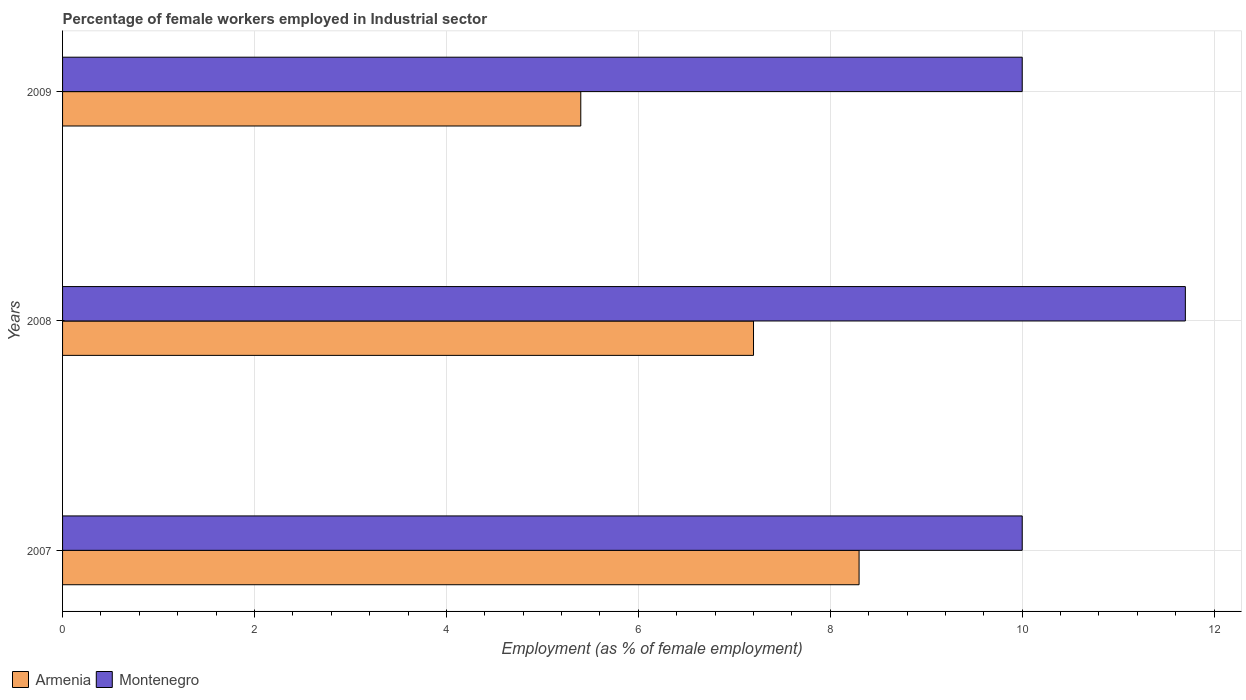Are the number of bars per tick equal to the number of legend labels?
Keep it short and to the point. Yes. Are the number of bars on each tick of the Y-axis equal?
Keep it short and to the point. Yes. How many bars are there on the 1st tick from the top?
Give a very brief answer. 2. What is the label of the 2nd group of bars from the top?
Your response must be concise. 2008. In how many cases, is the number of bars for a given year not equal to the number of legend labels?
Keep it short and to the point. 0. Across all years, what is the maximum percentage of females employed in Industrial sector in Montenegro?
Your answer should be very brief. 11.7. In which year was the percentage of females employed in Industrial sector in Montenegro minimum?
Provide a succinct answer. 2007. What is the total percentage of females employed in Industrial sector in Montenegro in the graph?
Provide a short and direct response. 31.7. What is the difference between the percentage of females employed in Industrial sector in Montenegro in 2009 and the percentage of females employed in Industrial sector in Armenia in 2007?
Offer a terse response. 1.7. What is the average percentage of females employed in Industrial sector in Armenia per year?
Make the answer very short. 6.97. In the year 2007, what is the difference between the percentage of females employed in Industrial sector in Armenia and percentage of females employed in Industrial sector in Montenegro?
Provide a short and direct response. -1.7. In how many years, is the percentage of females employed in Industrial sector in Armenia greater than 6 %?
Your answer should be very brief. 2. What is the ratio of the percentage of females employed in Industrial sector in Armenia in 2007 to that in 2009?
Keep it short and to the point. 1.54. Is the percentage of females employed in Industrial sector in Armenia in 2007 less than that in 2009?
Provide a short and direct response. No. Is the difference between the percentage of females employed in Industrial sector in Armenia in 2007 and 2008 greater than the difference between the percentage of females employed in Industrial sector in Montenegro in 2007 and 2008?
Keep it short and to the point. Yes. What is the difference between the highest and the second highest percentage of females employed in Industrial sector in Armenia?
Give a very brief answer. 1.1. What is the difference between the highest and the lowest percentage of females employed in Industrial sector in Armenia?
Ensure brevity in your answer.  2.9. In how many years, is the percentage of females employed in Industrial sector in Montenegro greater than the average percentage of females employed in Industrial sector in Montenegro taken over all years?
Keep it short and to the point. 1. Is the sum of the percentage of females employed in Industrial sector in Armenia in 2007 and 2008 greater than the maximum percentage of females employed in Industrial sector in Montenegro across all years?
Ensure brevity in your answer.  Yes. What does the 1st bar from the top in 2008 represents?
Provide a succinct answer. Montenegro. What does the 1st bar from the bottom in 2009 represents?
Give a very brief answer. Armenia. How many years are there in the graph?
Make the answer very short. 3. What is the difference between two consecutive major ticks on the X-axis?
Provide a short and direct response. 2. Does the graph contain any zero values?
Provide a short and direct response. No. Where does the legend appear in the graph?
Your response must be concise. Bottom left. What is the title of the graph?
Your answer should be compact. Percentage of female workers employed in Industrial sector. What is the label or title of the X-axis?
Provide a succinct answer. Employment (as % of female employment). What is the label or title of the Y-axis?
Ensure brevity in your answer.  Years. What is the Employment (as % of female employment) in Armenia in 2007?
Offer a very short reply. 8.3. What is the Employment (as % of female employment) of Montenegro in 2007?
Your answer should be compact. 10. What is the Employment (as % of female employment) in Armenia in 2008?
Make the answer very short. 7.2. What is the Employment (as % of female employment) of Montenegro in 2008?
Keep it short and to the point. 11.7. What is the Employment (as % of female employment) in Armenia in 2009?
Give a very brief answer. 5.4. Across all years, what is the maximum Employment (as % of female employment) in Armenia?
Keep it short and to the point. 8.3. Across all years, what is the maximum Employment (as % of female employment) of Montenegro?
Make the answer very short. 11.7. Across all years, what is the minimum Employment (as % of female employment) of Armenia?
Keep it short and to the point. 5.4. Across all years, what is the minimum Employment (as % of female employment) of Montenegro?
Keep it short and to the point. 10. What is the total Employment (as % of female employment) in Armenia in the graph?
Offer a terse response. 20.9. What is the total Employment (as % of female employment) of Montenegro in the graph?
Make the answer very short. 31.7. What is the difference between the Employment (as % of female employment) of Armenia in 2007 and that in 2008?
Give a very brief answer. 1.1. What is the difference between the Employment (as % of female employment) in Montenegro in 2007 and that in 2008?
Offer a very short reply. -1.7. What is the difference between the Employment (as % of female employment) in Armenia in 2007 and that in 2009?
Give a very brief answer. 2.9. What is the difference between the Employment (as % of female employment) of Montenegro in 2007 and that in 2009?
Offer a terse response. 0. What is the difference between the Employment (as % of female employment) of Armenia in 2008 and that in 2009?
Your answer should be compact. 1.8. What is the difference between the Employment (as % of female employment) of Armenia in 2007 and the Employment (as % of female employment) of Montenegro in 2008?
Give a very brief answer. -3.4. What is the difference between the Employment (as % of female employment) of Armenia in 2008 and the Employment (as % of female employment) of Montenegro in 2009?
Offer a very short reply. -2.8. What is the average Employment (as % of female employment) in Armenia per year?
Offer a terse response. 6.97. What is the average Employment (as % of female employment) in Montenegro per year?
Ensure brevity in your answer.  10.57. What is the ratio of the Employment (as % of female employment) of Armenia in 2007 to that in 2008?
Make the answer very short. 1.15. What is the ratio of the Employment (as % of female employment) in Montenegro in 2007 to that in 2008?
Ensure brevity in your answer.  0.85. What is the ratio of the Employment (as % of female employment) in Armenia in 2007 to that in 2009?
Provide a short and direct response. 1.54. What is the ratio of the Employment (as % of female employment) in Montenegro in 2007 to that in 2009?
Your answer should be very brief. 1. What is the ratio of the Employment (as % of female employment) in Montenegro in 2008 to that in 2009?
Keep it short and to the point. 1.17. What is the difference between the highest and the second highest Employment (as % of female employment) of Armenia?
Provide a short and direct response. 1.1. What is the difference between the highest and the second highest Employment (as % of female employment) of Montenegro?
Keep it short and to the point. 1.7. What is the difference between the highest and the lowest Employment (as % of female employment) of Armenia?
Offer a very short reply. 2.9. What is the difference between the highest and the lowest Employment (as % of female employment) in Montenegro?
Provide a succinct answer. 1.7. 